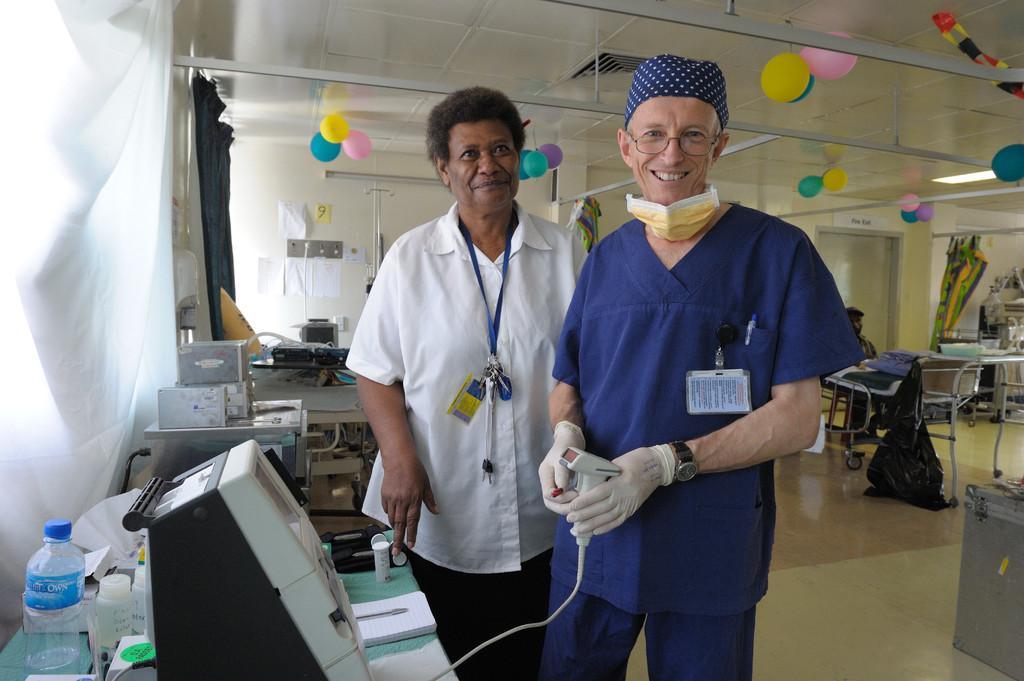Can you describe this image briefly? In this picture we can see 2 people wearing aprons standing in a room and smiling at someone. Here we can see tables, chairs, curtains, doors, a bottle and we can also see balloons on the ceiling wall. 